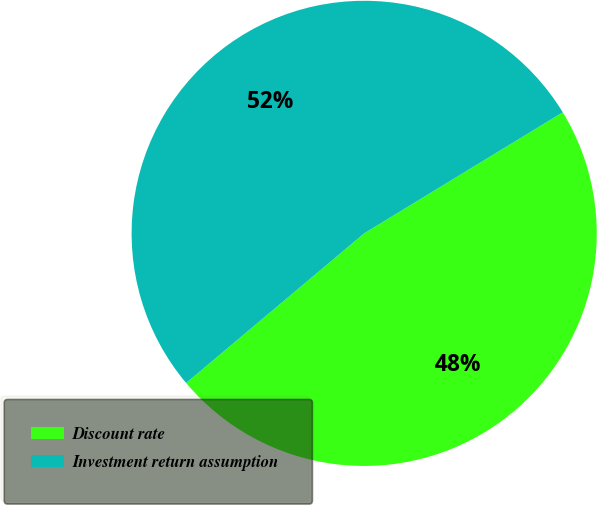Convert chart. <chart><loc_0><loc_0><loc_500><loc_500><pie_chart><fcel>Discount rate<fcel>Investment return assumption<nl><fcel>47.59%<fcel>52.41%<nl></chart> 